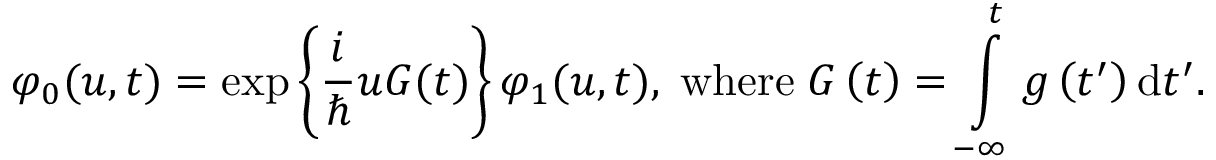Convert formula to latex. <formula><loc_0><loc_0><loc_500><loc_500>\varphi _ { 0 } ( u , t ) = \exp \left \{ \frac { i } { } u G ( t ) \right \} \varphi _ { 1 } ( u , t ) , \, w h e r e \, G \left ( t \right ) = \int o p _ { - \infty } ^ { t } g \left ( t ^ { \prime } \right ) d t ^ { \prime } .</formula> 